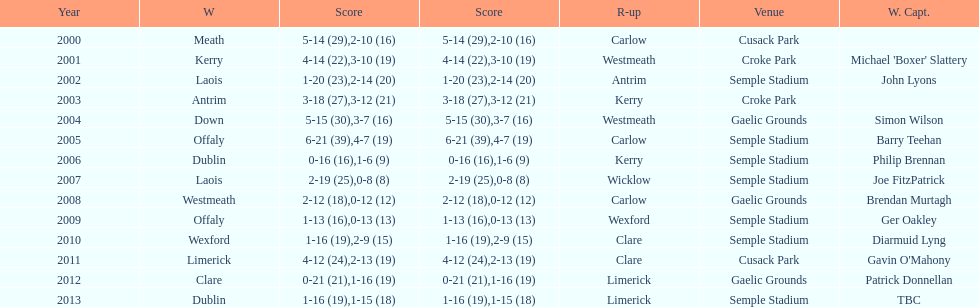Who scored the least? Wicklow. 